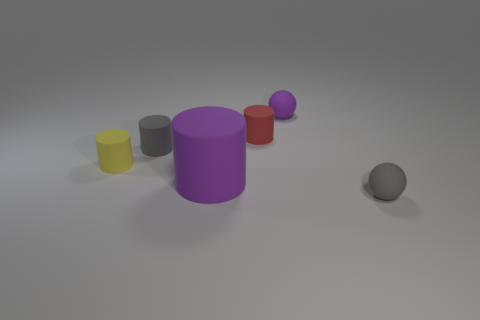Subtract all red cylinders. How many cylinders are left? 3 Subtract all gray cylinders. How many cylinders are left? 3 Add 2 large brown shiny spheres. How many objects exist? 8 Subtract all blue cylinders. Subtract all red cubes. How many cylinders are left? 4 Subtract all cylinders. How many objects are left? 2 Add 2 cyan shiny objects. How many cyan shiny objects exist? 2 Subtract 0 cyan cubes. How many objects are left? 6 Subtract all tiny red cylinders. Subtract all red cylinders. How many objects are left? 4 Add 6 red cylinders. How many red cylinders are left? 7 